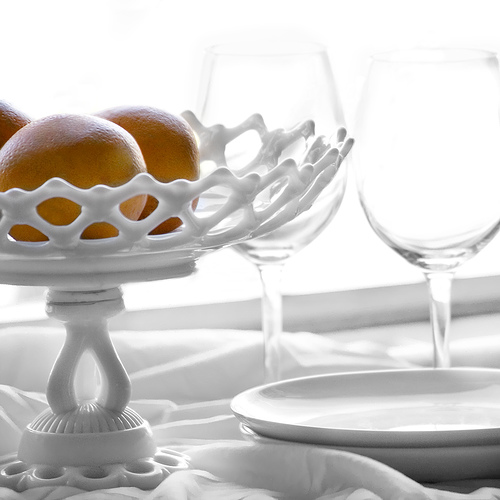<image>
Is there a orange behind the tray? No. The orange is not behind the tray. From this viewpoint, the orange appears to be positioned elsewhere in the scene. Is there a glass next to the glass? Yes. The glass is positioned adjacent to the glass, located nearby in the same general area. 